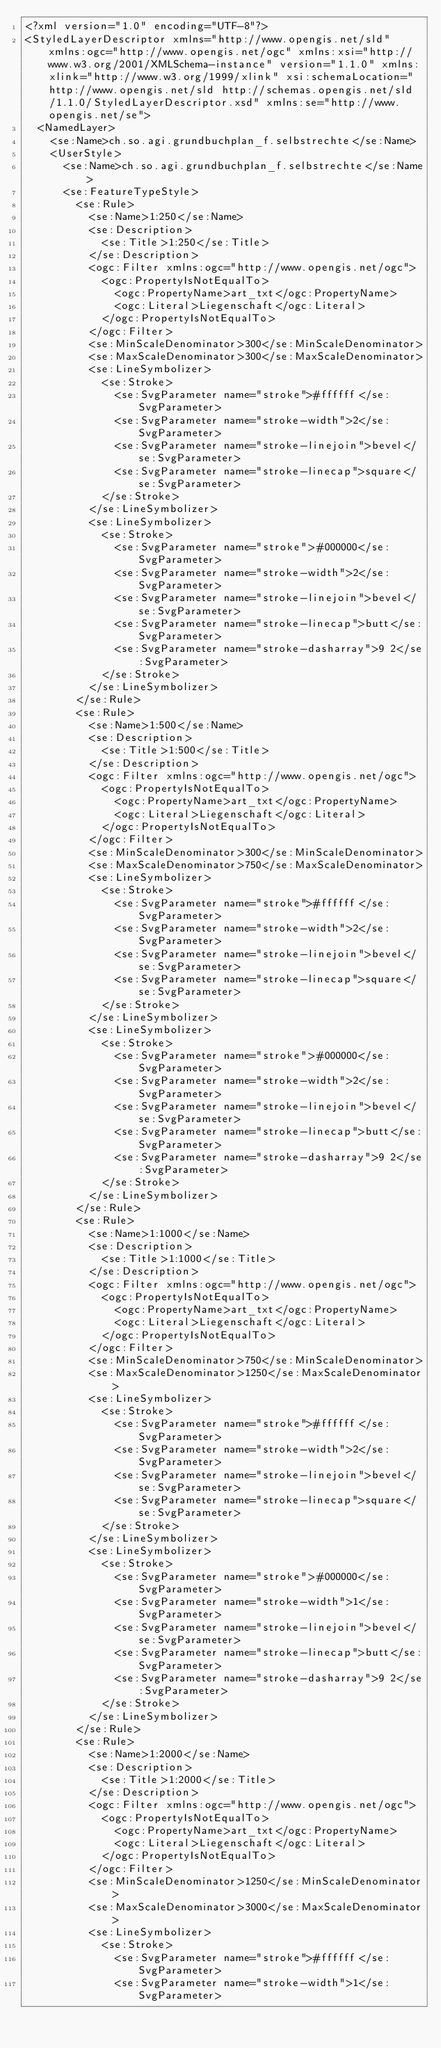Convert code to text. <code><loc_0><loc_0><loc_500><loc_500><_Scheme_><?xml version="1.0" encoding="UTF-8"?>
<StyledLayerDescriptor xmlns="http://www.opengis.net/sld" xmlns:ogc="http://www.opengis.net/ogc" xmlns:xsi="http://www.w3.org/2001/XMLSchema-instance" version="1.1.0" xmlns:xlink="http://www.w3.org/1999/xlink" xsi:schemaLocation="http://www.opengis.net/sld http://schemas.opengis.net/sld/1.1.0/StyledLayerDescriptor.xsd" xmlns:se="http://www.opengis.net/se">
  <NamedLayer>
    <se:Name>ch.so.agi.grundbuchplan_f.selbstrechte</se:Name>
    <UserStyle>
      <se:Name>ch.so.agi.grundbuchplan_f.selbstrechte</se:Name>
      <se:FeatureTypeStyle>
        <se:Rule>
          <se:Name>1:250</se:Name>
          <se:Description>
            <se:Title>1:250</se:Title>
          </se:Description>
          <ogc:Filter xmlns:ogc="http://www.opengis.net/ogc">
            <ogc:PropertyIsNotEqualTo>
              <ogc:PropertyName>art_txt</ogc:PropertyName>
              <ogc:Literal>Liegenschaft</ogc:Literal>
            </ogc:PropertyIsNotEqualTo>
          </ogc:Filter>
          <se:MinScaleDenominator>300</se:MinScaleDenominator>
          <se:MaxScaleDenominator>300</se:MaxScaleDenominator>
          <se:LineSymbolizer>
            <se:Stroke>
              <se:SvgParameter name="stroke">#ffffff</se:SvgParameter>
              <se:SvgParameter name="stroke-width">2</se:SvgParameter>
              <se:SvgParameter name="stroke-linejoin">bevel</se:SvgParameter>
              <se:SvgParameter name="stroke-linecap">square</se:SvgParameter>
            </se:Stroke>
          </se:LineSymbolizer>
          <se:LineSymbolizer>
            <se:Stroke>
              <se:SvgParameter name="stroke">#000000</se:SvgParameter>
              <se:SvgParameter name="stroke-width">2</se:SvgParameter>
              <se:SvgParameter name="stroke-linejoin">bevel</se:SvgParameter>
              <se:SvgParameter name="stroke-linecap">butt</se:SvgParameter>
              <se:SvgParameter name="stroke-dasharray">9 2</se:SvgParameter>
            </se:Stroke>
          </se:LineSymbolizer>
        </se:Rule>
        <se:Rule>
          <se:Name>1:500</se:Name>
          <se:Description>
            <se:Title>1:500</se:Title>
          </se:Description>
          <ogc:Filter xmlns:ogc="http://www.opengis.net/ogc">
            <ogc:PropertyIsNotEqualTo>
              <ogc:PropertyName>art_txt</ogc:PropertyName>
              <ogc:Literal>Liegenschaft</ogc:Literal>
            </ogc:PropertyIsNotEqualTo>
          </ogc:Filter>
          <se:MinScaleDenominator>300</se:MinScaleDenominator>
          <se:MaxScaleDenominator>750</se:MaxScaleDenominator>
          <se:LineSymbolizer>
            <se:Stroke>
              <se:SvgParameter name="stroke">#ffffff</se:SvgParameter>
              <se:SvgParameter name="stroke-width">2</se:SvgParameter>
              <se:SvgParameter name="stroke-linejoin">bevel</se:SvgParameter>
              <se:SvgParameter name="stroke-linecap">square</se:SvgParameter>
            </se:Stroke>
          </se:LineSymbolizer>
          <se:LineSymbolizer>
            <se:Stroke>
              <se:SvgParameter name="stroke">#000000</se:SvgParameter>
              <se:SvgParameter name="stroke-width">2</se:SvgParameter>
              <se:SvgParameter name="stroke-linejoin">bevel</se:SvgParameter>
              <se:SvgParameter name="stroke-linecap">butt</se:SvgParameter>
              <se:SvgParameter name="stroke-dasharray">9 2</se:SvgParameter>
            </se:Stroke>
          </se:LineSymbolizer>
        </se:Rule>
        <se:Rule>
          <se:Name>1:1000</se:Name>
          <se:Description>
            <se:Title>1:1000</se:Title>
          </se:Description>
          <ogc:Filter xmlns:ogc="http://www.opengis.net/ogc">
            <ogc:PropertyIsNotEqualTo>
              <ogc:PropertyName>art_txt</ogc:PropertyName>
              <ogc:Literal>Liegenschaft</ogc:Literal>
            </ogc:PropertyIsNotEqualTo>
          </ogc:Filter>
          <se:MinScaleDenominator>750</se:MinScaleDenominator>
          <se:MaxScaleDenominator>1250</se:MaxScaleDenominator>
          <se:LineSymbolizer>
            <se:Stroke>
              <se:SvgParameter name="stroke">#ffffff</se:SvgParameter>
              <se:SvgParameter name="stroke-width">2</se:SvgParameter>
              <se:SvgParameter name="stroke-linejoin">bevel</se:SvgParameter>
              <se:SvgParameter name="stroke-linecap">square</se:SvgParameter>
            </se:Stroke>
          </se:LineSymbolizer>
          <se:LineSymbolizer>
            <se:Stroke>
              <se:SvgParameter name="stroke">#000000</se:SvgParameter>
              <se:SvgParameter name="stroke-width">1</se:SvgParameter>
              <se:SvgParameter name="stroke-linejoin">bevel</se:SvgParameter>
              <se:SvgParameter name="stroke-linecap">butt</se:SvgParameter>
              <se:SvgParameter name="stroke-dasharray">9 2</se:SvgParameter>
            </se:Stroke>
          </se:LineSymbolizer>
        </se:Rule>
        <se:Rule>
          <se:Name>1:2000</se:Name>
          <se:Description>
            <se:Title>1:2000</se:Title>
          </se:Description>
          <ogc:Filter xmlns:ogc="http://www.opengis.net/ogc">
            <ogc:PropertyIsNotEqualTo>
              <ogc:PropertyName>art_txt</ogc:PropertyName>
              <ogc:Literal>Liegenschaft</ogc:Literal>
            </ogc:PropertyIsNotEqualTo>
          </ogc:Filter>
          <se:MinScaleDenominator>1250</se:MinScaleDenominator>
          <se:MaxScaleDenominator>3000</se:MaxScaleDenominator>
          <se:LineSymbolizer>
            <se:Stroke>
              <se:SvgParameter name="stroke">#ffffff</se:SvgParameter>
              <se:SvgParameter name="stroke-width">1</se:SvgParameter></code> 